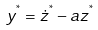Convert formula to latex. <formula><loc_0><loc_0><loc_500><loc_500>y ^ { ^ { * } } = \dot { z } ^ { ^ { * } } - a z ^ { ^ { * } }</formula> 